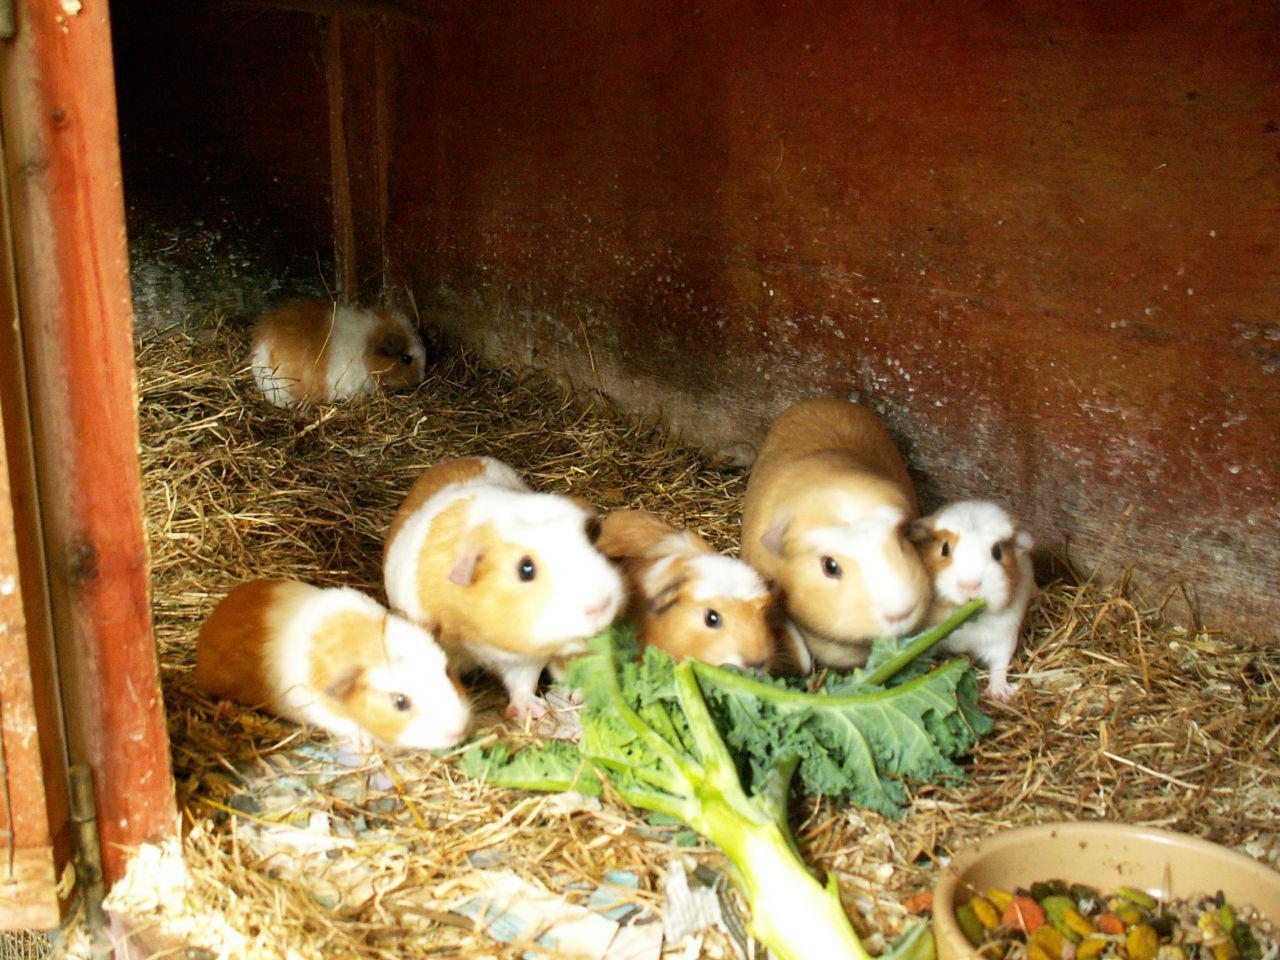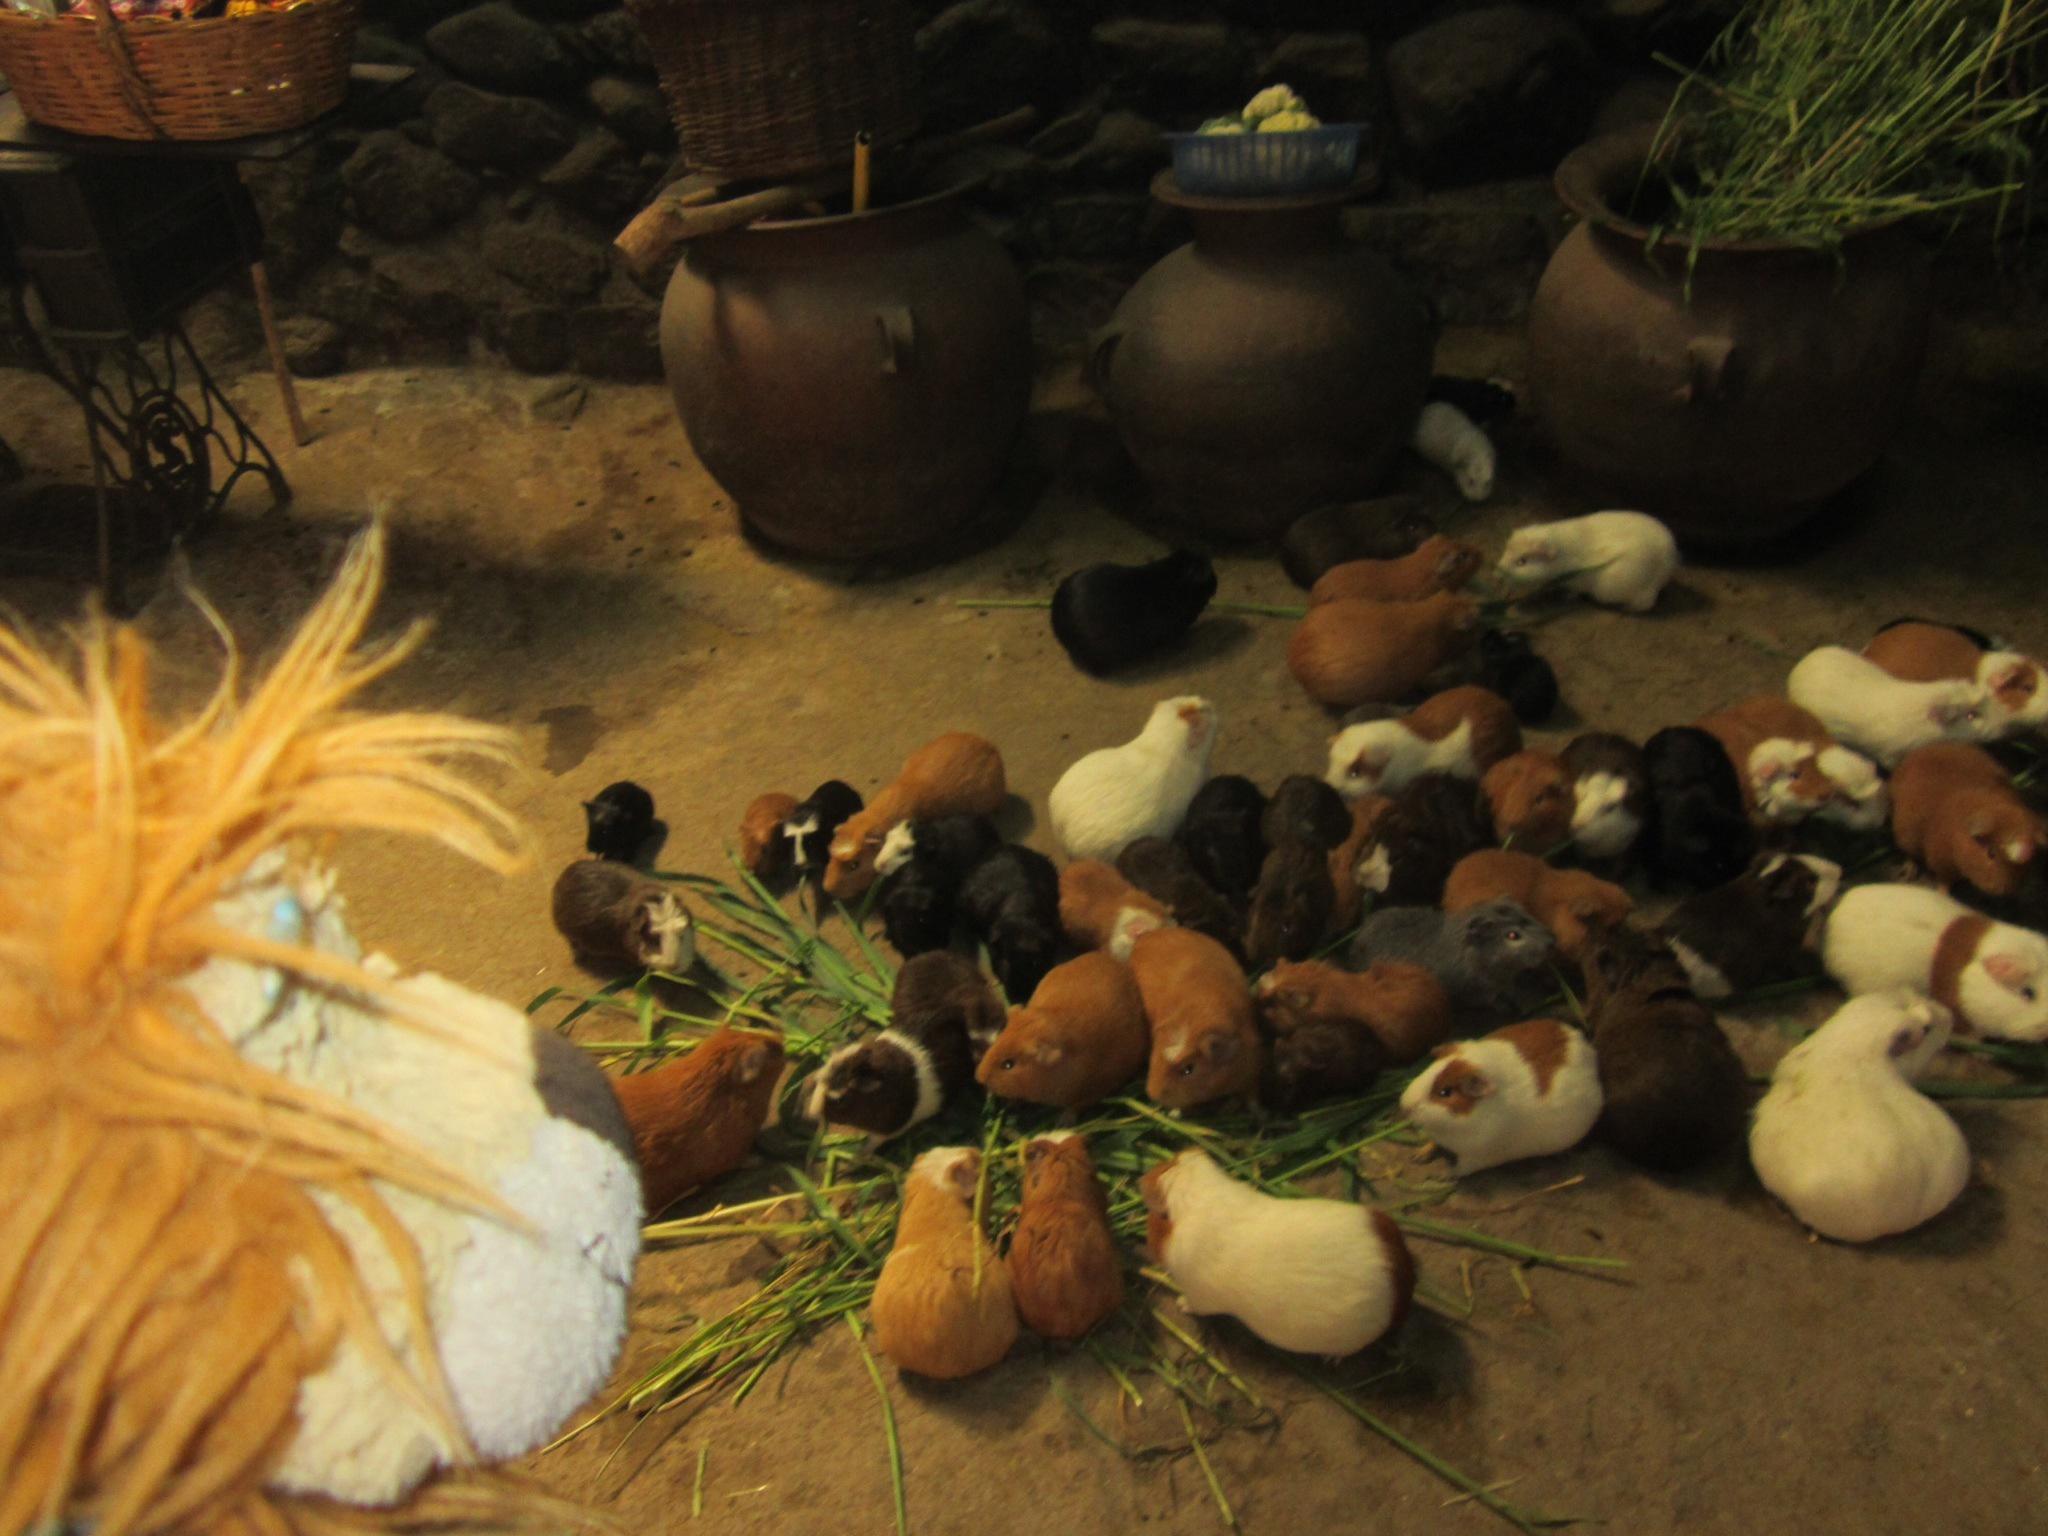The first image is the image on the left, the second image is the image on the right. For the images shown, is this caption "There are exactly six guinea pigs in the left image and some of them are eating." true? Answer yes or no. Yes. The first image is the image on the left, the second image is the image on the right. Analyze the images presented: Is the assertion "Left image shows tan and white hamsters with green leafy items to eat in front of them." valid? Answer yes or no. Yes. 